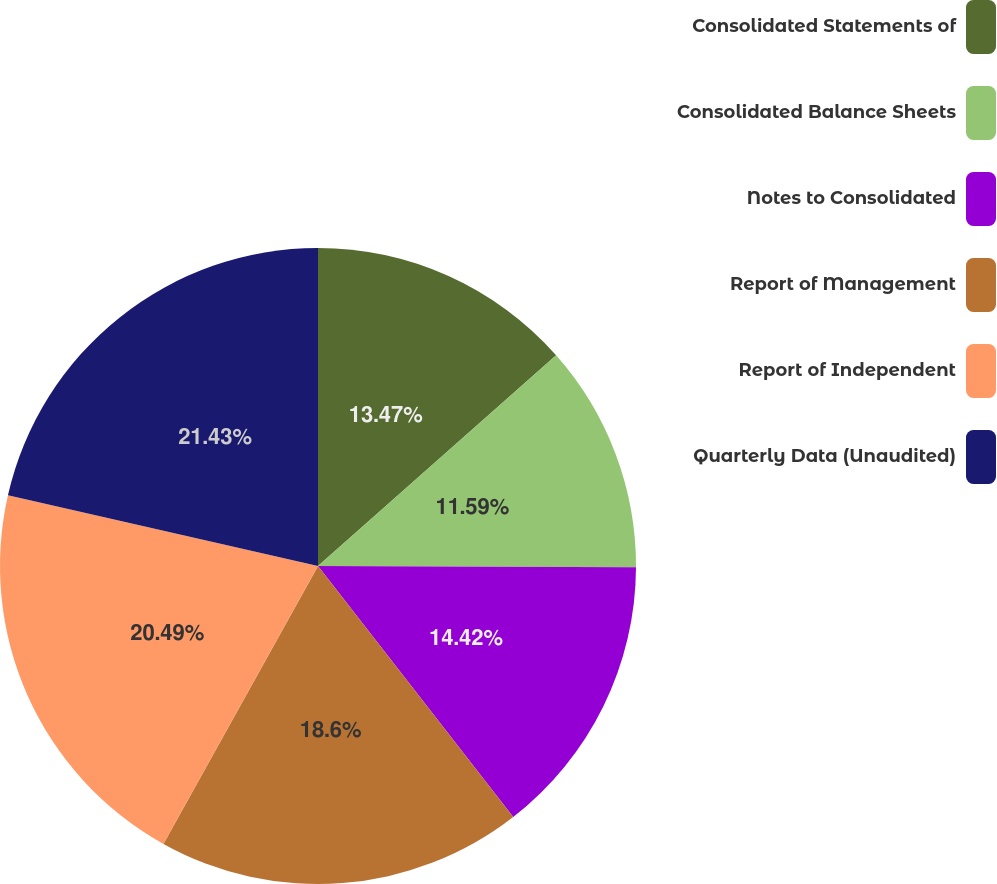Convert chart to OTSL. <chart><loc_0><loc_0><loc_500><loc_500><pie_chart><fcel>Consolidated Statements of<fcel>Consolidated Balance Sheets<fcel>Notes to Consolidated<fcel>Report of Management<fcel>Report of Independent<fcel>Quarterly Data (Unaudited)<nl><fcel>13.47%<fcel>11.59%<fcel>14.42%<fcel>18.6%<fcel>20.49%<fcel>21.43%<nl></chart> 